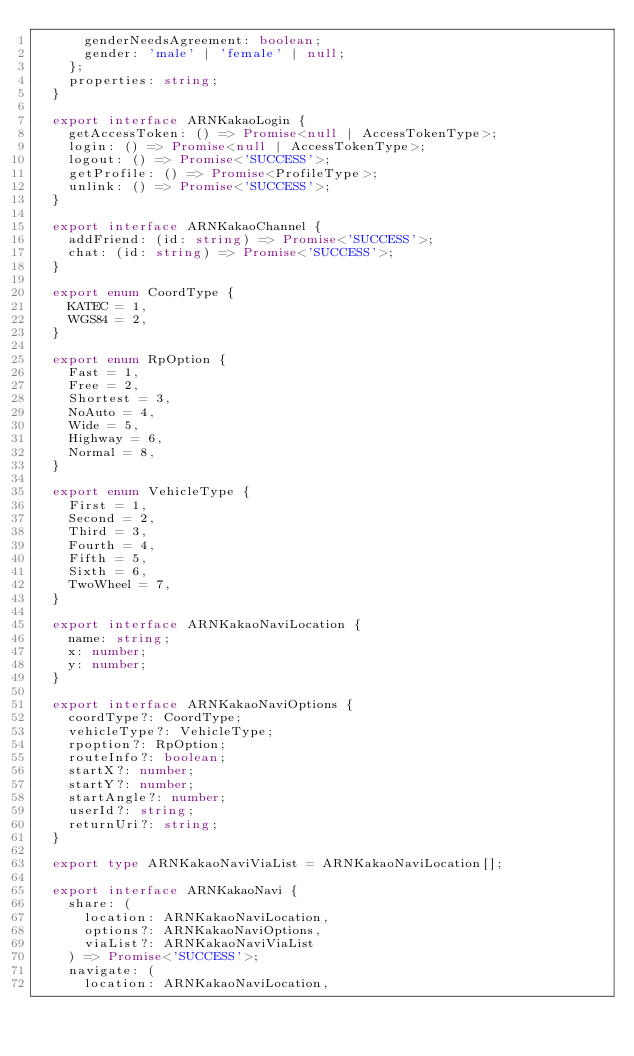Convert code to text. <code><loc_0><loc_0><loc_500><loc_500><_TypeScript_>      genderNeedsAgreement: boolean;
      gender: 'male' | 'female' | null;
    };
    properties: string;
  }

  export interface ARNKakaoLogin {
    getAccessToken: () => Promise<null | AccessTokenType>;
    login: () => Promise<null | AccessTokenType>;
    logout: () => Promise<'SUCCESS'>;
    getProfile: () => Promise<ProfileType>;
    unlink: () => Promise<'SUCCESS'>;
  }

  export interface ARNKakaoChannel {
    addFriend: (id: string) => Promise<'SUCCESS'>;
    chat: (id: string) => Promise<'SUCCESS'>;
  }

  export enum CoordType {
    KATEC = 1,
    WGS84 = 2,
  }

  export enum RpOption {
    Fast = 1,
    Free = 2,
    Shortest = 3,
    NoAuto = 4,
    Wide = 5,
    Highway = 6,
    Normal = 8,
  }

  export enum VehicleType {
    First = 1,
    Second = 2,
    Third = 3,
    Fourth = 4,
    Fifth = 5,
    Sixth = 6,
    TwoWheel = 7,
  }

  export interface ARNKakaoNaviLocation {
    name: string;
    x: number;
    y: number;
  }

  export interface ARNKakaoNaviOptions {
    coordType?: CoordType;
    vehicleType?: VehicleType;
    rpoption?: RpOption;
    routeInfo?: boolean;
    startX?: number;
    startY?: number;
    startAngle?: number;
    userId?: string;
    returnUri?: string;
  }

  export type ARNKakaoNaviViaList = ARNKakaoNaviLocation[];

  export interface ARNKakaoNavi {
    share: (
      location: ARNKakaoNaviLocation,
      options?: ARNKakaoNaviOptions,
      viaList?: ARNKakaoNaviViaList
    ) => Promise<'SUCCESS'>;
    navigate: (
      location: ARNKakaoNaviLocation,</code> 